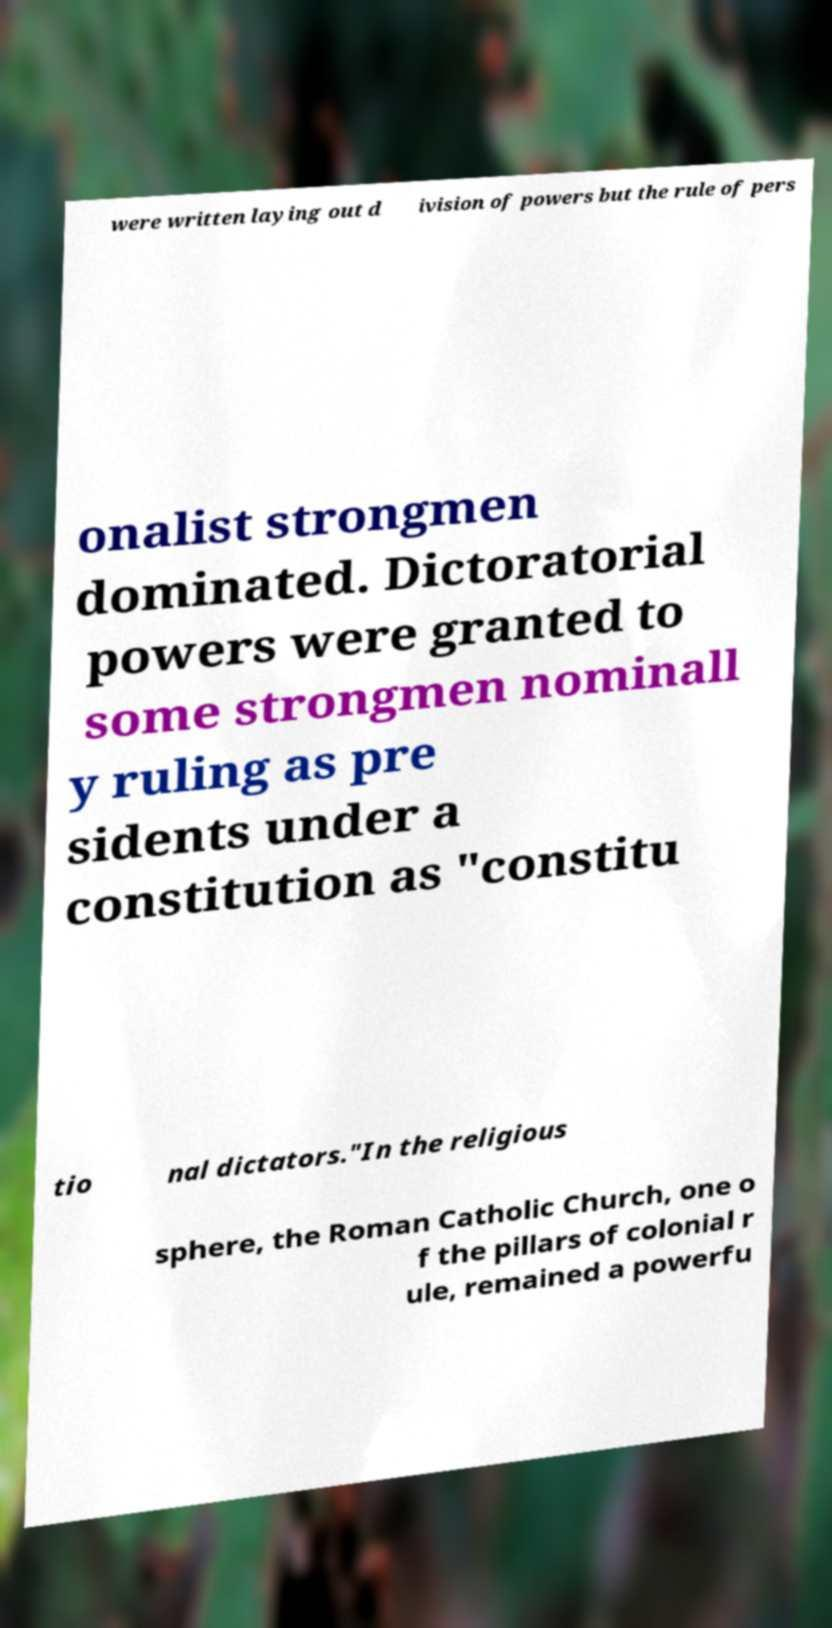Could you extract and type out the text from this image? were written laying out d ivision of powers but the rule of pers onalist strongmen dominated. Dictoratorial powers were granted to some strongmen nominall y ruling as pre sidents under a constitution as "constitu tio nal dictators."In the religious sphere, the Roman Catholic Church, one o f the pillars of colonial r ule, remained a powerfu 